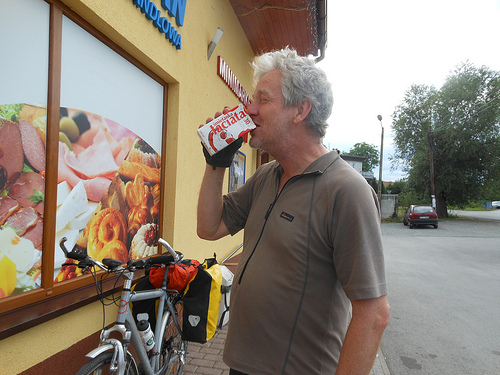<image>
Is the milk behind the man? No. The milk is not behind the man. From this viewpoint, the milk appears to be positioned elsewhere in the scene. 